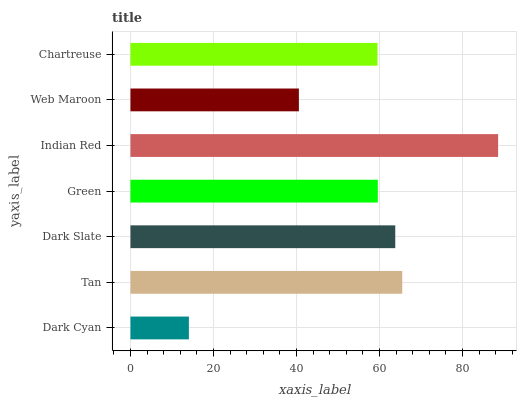Is Dark Cyan the minimum?
Answer yes or no. Yes. Is Indian Red the maximum?
Answer yes or no. Yes. Is Tan the minimum?
Answer yes or no. No. Is Tan the maximum?
Answer yes or no. No. Is Tan greater than Dark Cyan?
Answer yes or no. Yes. Is Dark Cyan less than Tan?
Answer yes or no. Yes. Is Dark Cyan greater than Tan?
Answer yes or no. No. Is Tan less than Dark Cyan?
Answer yes or no. No. Is Green the high median?
Answer yes or no. Yes. Is Green the low median?
Answer yes or no. Yes. Is Web Maroon the high median?
Answer yes or no. No. Is Dark Slate the low median?
Answer yes or no. No. 